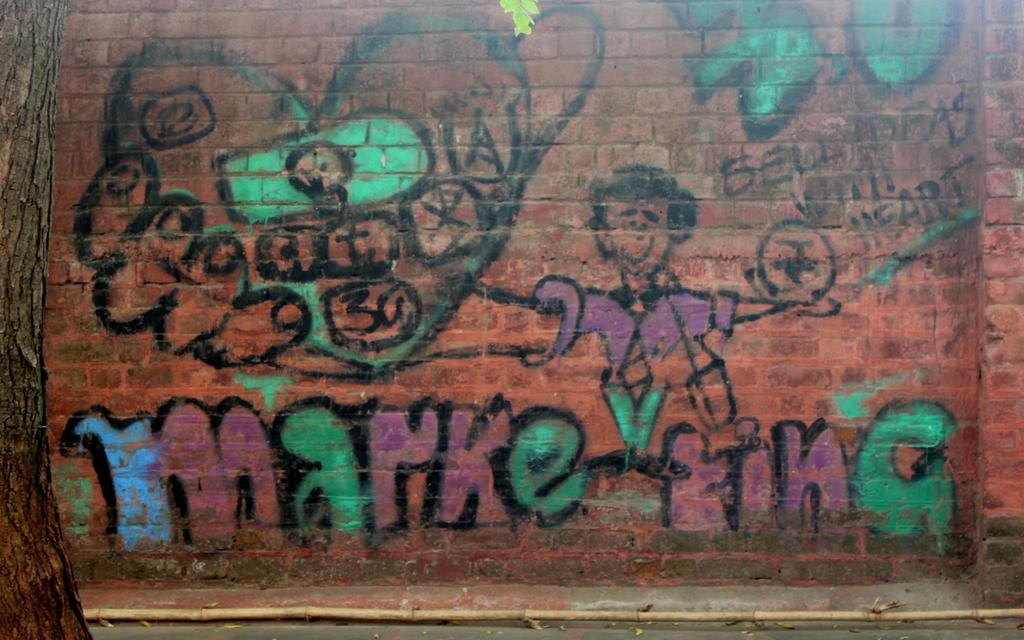What type of art can be seen on the wall in the image? There is graffiti art on the wall in the image. What other elements are present in the image besides the graffiti art? There is a tree on the left side of the image. What colors are used in the graffiti art? The graffiti art includes green, violet, and blue colors. What type of butter is being used in the graffiti art? There is no butter present in the image; it features graffiti art on a wall with a tree on the left side. 